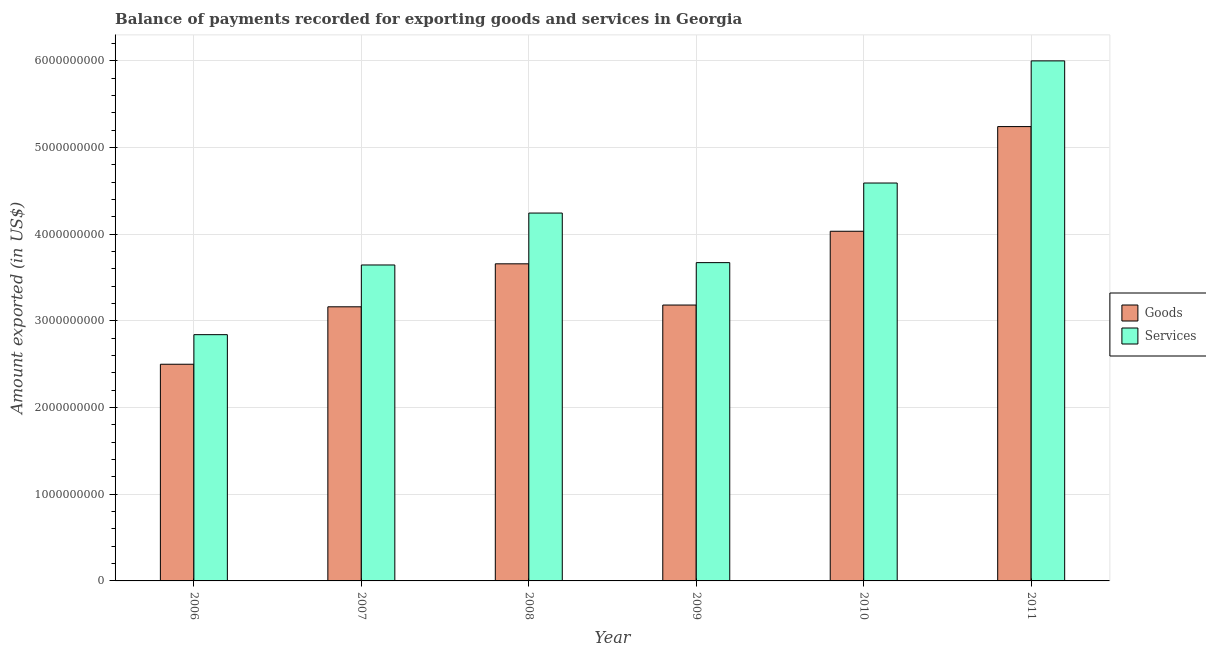How many groups of bars are there?
Your answer should be very brief. 6. Are the number of bars per tick equal to the number of legend labels?
Your answer should be compact. Yes. How many bars are there on the 4th tick from the left?
Offer a terse response. 2. What is the amount of goods exported in 2006?
Offer a very short reply. 2.50e+09. Across all years, what is the maximum amount of goods exported?
Ensure brevity in your answer.  5.24e+09. Across all years, what is the minimum amount of goods exported?
Provide a succinct answer. 2.50e+09. In which year was the amount of services exported maximum?
Your answer should be compact. 2011. What is the total amount of goods exported in the graph?
Offer a terse response. 2.18e+1. What is the difference between the amount of goods exported in 2006 and that in 2007?
Your answer should be compact. -6.63e+08. What is the difference between the amount of services exported in 2006 and the amount of goods exported in 2007?
Offer a very short reply. -8.04e+08. What is the average amount of goods exported per year?
Make the answer very short. 3.63e+09. In the year 2009, what is the difference between the amount of services exported and amount of goods exported?
Give a very brief answer. 0. What is the ratio of the amount of goods exported in 2008 to that in 2011?
Provide a succinct answer. 0.7. What is the difference between the highest and the second highest amount of goods exported?
Your answer should be very brief. 1.21e+09. What is the difference between the highest and the lowest amount of services exported?
Provide a short and direct response. 3.16e+09. What does the 1st bar from the left in 2007 represents?
Make the answer very short. Goods. What does the 1st bar from the right in 2011 represents?
Offer a very short reply. Services. What is the difference between two consecutive major ticks on the Y-axis?
Offer a terse response. 1.00e+09. Are the values on the major ticks of Y-axis written in scientific E-notation?
Your answer should be compact. No. Where does the legend appear in the graph?
Your answer should be compact. Center right. How many legend labels are there?
Provide a short and direct response. 2. What is the title of the graph?
Provide a succinct answer. Balance of payments recorded for exporting goods and services in Georgia. Does "Taxes" appear as one of the legend labels in the graph?
Your response must be concise. No. What is the label or title of the X-axis?
Your response must be concise. Year. What is the label or title of the Y-axis?
Keep it short and to the point. Amount exported (in US$). What is the Amount exported (in US$) in Goods in 2006?
Offer a very short reply. 2.50e+09. What is the Amount exported (in US$) of Services in 2006?
Provide a short and direct response. 2.84e+09. What is the Amount exported (in US$) of Goods in 2007?
Offer a terse response. 3.16e+09. What is the Amount exported (in US$) in Services in 2007?
Provide a short and direct response. 3.65e+09. What is the Amount exported (in US$) in Goods in 2008?
Provide a short and direct response. 3.66e+09. What is the Amount exported (in US$) in Services in 2008?
Your answer should be compact. 4.24e+09. What is the Amount exported (in US$) in Goods in 2009?
Ensure brevity in your answer.  3.18e+09. What is the Amount exported (in US$) of Services in 2009?
Your response must be concise. 3.67e+09. What is the Amount exported (in US$) of Goods in 2010?
Your answer should be compact. 4.03e+09. What is the Amount exported (in US$) in Services in 2010?
Your response must be concise. 4.59e+09. What is the Amount exported (in US$) of Goods in 2011?
Provide a succinct answer. 5.24e+09. What is the Amount exported (in US$) in Services in 2011?
Provide a succinct answer. 6.00e+09. Across all years, what is the maximum Amount exported (in US$) of Goods?
Keep it short and to the point. 5.24e+09. Across all years, what is the maximum Amount exported (in US$) of Services?
Your response must be concise. 6.00e+09. Across all years, what is the minimum Amount exported (in US$) in Goods?
Your answer should be compact. 2.50e+09. Across all years, what is the minimum Amount exported (in US$) in Services?
Your answer should be very brief. 2.84e+09. What is the total Amount exported (in US$) in Goods in the graph?
Make the answer very short. 2.18e+1. What is the total Amount exported (in US$) in Services in the graph?
Offer a very short reply. 2.50e+1. What is the difference between the Amount exported (in US$) of Goods in 2006 and that in 2007?
Give a very brief answer. -6.63e+08. What is the difference between the Amount exported (in US$) of Services in 2006 and that in 2007?
Provide a short and direct response. -8.04e+08. What is the difference between the Amount exported (in US$) in Goods in 2006 and that in 2008?
Give a very brief answer. -1.16e+09. What is the difference between the Amount exported (in US$) in Services in 2006 and that in 2008?
Offer a terse response. -1.40e+09. What is the difference between the Amount exported (in US$) of Goods in 2006 and that in 2009?
Keep it short and to the point. -6.83e+08. What is the difference between the Amount exported (in US$) in Services in 2006 and that in 2009?
Make the answer very short. -8.31e+08. What is the difference between the Amount exported (in US$) in Goods in 2006 and that in 2010?
Ensure brevity in your answer.  -1.53e+09. What is the difference between the Amount exported (in US$) in Services in 2006 and that in 2010?
Give a very brief answer. -1.75e+09. What is the difference between the Amount exported (in US$) of Goods in 2006 and that in 2011?
Make the answer very short. -2.74e+09. What is the difference between the Amount exported (in US$) of Services in 2006 and that in 2011?
Keep it short and to the point. -3.16e+09. What is the difference between the Amount exported (in US$) of Goods in 2007 and that in 2008?
Give a very brief answer. -4.96e+08. What is the difference between the Amount exported (in US$) of Services in 2007 and that in 2008?
Ensure brevity in your answer.  -5.99e+08. What is the difference between the Amount exported (in US$) of Goods in 2007 and that in 2009?
Ensure brevity in your answer.  -2.04e+07. What is the difference between the Amount exported (in US$) of Services in 2007 and that in 2009?
Make the answer very short. -2.71e+07. What is the difference between the Amount exported (in US$) in Goods in 2007 and that in 2010?
Provide a short and direct response. -8.71e+08. What is the difference between the Amount exported (in US$) of Services in 2007 and that in 2010?
Your response must be concise. -9.46e+08. What is the difference between the Amount exported (in US$) of Goods in 2007 and that in 2011?
Offer a very short reply. -2.08e+09. What is the difference between the Amount exported (in US$) in Services in 2007 and that in 2011?
Your answer should be compact. -2.35e+09. What is the difference between the Amount exported (in US$) in Goods in 2008 and that in 2009?
Make the answer very short. 4.75e+08. What is the difference between the Amount exported (in US$) of Services in 2008 and that in 2009?
Ensure brevity in your answer.  5.72e+08. What is the difference between the Amount exported (in US$) of Goods in 2008 and that in 2010?
Offer a terse response. -3.76e+08. What is the difference between the Amount exported (in US$) of Services in 2008 and that in 2010?
Make the answer very short. -3.46e+08. What is the difference between the Amount exported (in US$) in Goods in 2008 and that in 2011?
Make the answer very short. -1.58e+09. What is the difference between the Amount exported (in US$) in Services in 2008 and that in 2011?
Offer a very short reply. -1.76e+09. What is the difference between the Amount exported (in US$) of Goods in 2009 and that in 2010?
Your answer should be compact. -8.51e+08. What is the difference between the Amount exported (in US$) of Services in 2009 and that in 2010?
Provide a succinct answer. -9.18e+08. What is the difference between the Amount exported (in US$) in Goods in 2009 and that in 2011?
Provide a short and direct response. -2.06e+09. What is the difference between the Amount exported (in US$) in Services in 2009 and that in 2011?
Provide a succinct answer. -2.33e+09. What is the difference between the Amount exported (in US$) of Goods in 2010 and that in 2011?
Give a very brief answer. -1.21e+09. What is the difference between the Amount exported (in US$) in Services in 2010 and that in 2011?
Your answer should be compact. -1.41e+09. What is the difference between the Amount exported (in US$) of Goods in 2006 and the Amount exported (in US$) of Services in 2007?
Keep it short and to the point. -1.15e+09. What is the difference between the Amount exported (in US$) of Goods in 2006 and the Amount exported (in US$) of Services in 2008?
Your response must be concise. -1.74e+09. What is the difference between the Amount exported (in US$) in Goods in 2006 and the Amount exported (in US$) in Services in 2009?
Your answer should be compact. -1.17e+09. What is the difference between the Amount exported (in US$) in Goods in 2006 and the Amount exported (in US$) in Services in 2010?
Your response must be concise. -2.09e+09. What is the difference between the Amount exported (in US$) in Goods in 2006 and the Amount exported (in US$) in Services in 2011?
Keep it short and to the point. -3.50e+09. What is the difference between the Amount exported (in US$) of Goods in 2007 and the Amount exported (in US$) of Services in 2008?
Make the answer very short. -1.08e+09. What is the difference between the Amount exported (in US$) in Goods in 2007 and the Amount exported (in US$) in Services in 2009?
Provide a succinct answer. -5.10e+08. What is the difference between the Amount exported (in US$) in Goods in 2007 and the Amount exported (in US$) in Services in 2010?
Provide a short and direct response. -1.43e+09. What is the difference between the Amount exported (in US$) of Goods in 2007 and the Amount exported (in US$) of Services in 2011?
Your answer should be compact. -2.84e+09. What is the difference between the Amount exported (in US$) in Goods in 2008 and the Amount exported (in US$) in Services in 2009?
Give a very brief answer. -1.38e+07. What is the difference between the Amount exported (in US$) in Goods in 2008 and the Amount exported (in US$) in Services in 2010?
Provide a short and direct response. -9.32e+08. What is the difference between the Amount exported (in US$) in Goods in 2008 and the Amount exported (in US$) in Services in 2011?
Offer a terse response. -2.34e+09. What is the difference between the Amount exported (in US$) of Goods in 2009 and the Amount exported (in US$) of Services in 2010?
Your answer should be compact. -1.41e+09. What is the difference between the Amount exported (in US$) in Goods in 2009 and the Amount exported (in US$) in Services in 2011?
Your answer should be compact. -2.82e+09. What is the difference between the Amount exported (in US$) in Goods in 2010 and the Amount exported (in US$) in Services in 2011?
Your answer should be very brief. -1.97e+09. What is the average Amount exported (in US$) of Goods per year?
Make the answer very short. 3.63e+09. What is the average Amount exported (in US$) in Services per year?
Offer a very short reply. 4.17e+09. In the year 2006, what is the difference between the Amount exported (in US$) in Goods and Amount exported (in US$) in Services?
Your answer should be compact. -3.41e+08. In the year 2007, what is the difference between the Amount exported (in US$) of Goods and Amount exported (in US$) of Services?
Ensure brevity in your answer.  -4.83e+08. In the year 2008, what is the difference between the Amount exported (in US$) of Goods and Amount exported (in US$) of Services?
Give a very brief answer. -5.86e+08. In the year 2009, what is the difference between the Amount exported (in US$) of Goods and Amount exported (in US$) of Services?
Keep it short and to the point. -4.89e+08. In the year 2010, what is the difference between the Amount exported (in US$) in Goods and Amount exported (in US$) in Services?
Your answer should be very brief. -5.57e+08. In the year 2011, what is the difference between the Amount exported (in US$) of Goods and Amount exported (in US$) of Services?
Offer a very short reply. -7.58e+08. What is the ratio of the Amount exported (in US$) in Goods in 2006 to that in 2007?
Provide a succinct answer. 0.79. What is the ratio of the Amount exported (in US$) in Services in 2006 to that in 2007?
Ensure brevity in your answer.  0.78. What is the ratio of the Amount exported (in US$) in Goods in 2006 to that in 2008?
Your answer should be very brief. 0.68. What is the ratio of the Amount exported (in US$) in Services in 2006 to that in 2008?
Your response must be concise. 0.67. What is the ratio of the Amount exported (in US$) of Goods in 2006 to that in 2009?
Offer a very short reply. 0.79. What is the ratio of the Amount exported (in US$) in Services in 2006 to that in 2009?
Your response must be concise. 0.77. What is the ratio of the Amount exported (in US$) in Goods in 2006 to that in 2010?
Your response must be concise. 0.62. What is the ratio of the Amount exported (in US$) of Services in 2006 to that in 2010?
Ensure brevity in your answer.  0.62. What is the ratio of the Amount exported (in US$) of Goods in 2006 to that in 2011?
Keep it short and to the point. 0.48. What is the ratio of the Amount exported (in US$) in Services in 2006 to that in 2011?
Keep it short and to the point. 0.47. What is the ratio of the Amount exported (in US$) of Goods in 2007 to that in 2008?
Your answer should be compact. 0.86. What is the ratio of the Amount exported (in US$) in Services in 2007 to that in 2008?
Your response must be concise. 0.86. What is the ratio of the Amount exported (in US$) in Goods in 2007 to that in 2009?
Offer a terse response. 0.99. What is the ratio of the Amount exported (in US$) of Goods in 2007 to that in 2010?
Offer a very short reply. 0.78. What is the ratio of the Amount exported (in US$) in Services in 2007 to that in 2010?
Make the answer very short. 0.79. What is the ratio of the Amount exported (in US$) in Goods in 2007 to that in 2011?
Your response must be concise. 0.6. What is the ratio of the Amount exported (in US$) in Services in 2007 to that in 2011?
Your answer should be very brief. 0.61. What is the ratio of the Amount exported (in US$) of Goods in 2008 to that in 2009?
Provide a short and direct response. 1.15. What is the ratio of the Amount exported (in US$) of Services in 2008 to that in 2009?
Your answer should be very brief. 1.16. What is the ratio of the Amount exported (in US$) of Goods in 2008 to that in 2010?
Your answer should be compact. 0.91. What is the ratio of the Amount exported (in US$) in Services in 2008 to that in 2010?
Offer a very short reply. 0.92. What is the ratio of the Amount exported (in US$) in Goods in 2008 to that in 2011?
Ensure brevity in your answer.  0.7. What is the ratio of the Amount exported (in US$) in Services in 2008 to that in 2011?
Offer a very short reply. 0.71. What is the ratio of the Amount exported (in US$) in Goods in 2009 to that in 2010?
Provide a short and direct response. 0.79. What is the ratio of the Amount exported (in US$) in Services in 2009 to that in 2010?
Offer a very short reply. 0.8. What is the ratio of the Amount exported (in US$) in Goods in 2009 to that in 2011?
Your response must be concise. 0.61. What is the ratio of the Amount exported (in US$) in Services in 2009 to that in 2011?
Keep it short and to the point. 0.61. What is the ratio of the Amount exported (in US$) in Goods in 2010 to that in 2011?
Your response must be concise. 0.77. What is the ratio of the Amount exported (in US$) of Services in 2010 to that in 2011?
Offer a very short reply. 0.77. What is the difference between the highest and the second highest Amount exported (in US$) of Goods?
Give a very brief answer. 1.21e+09. What is the difference between the highest and the second highest Amount exported (in US$) in Services?
Make the answer very short. 1.41e+09. What is the difference between the highest and the lowest Amount exported (in US$) in Goods?
Your answer should be very brief. 2.74e+09. What is the difference between the highest and the lowest Amount exported (in US$) of Services?
Keep it short and to the point. 3.16e+09. 